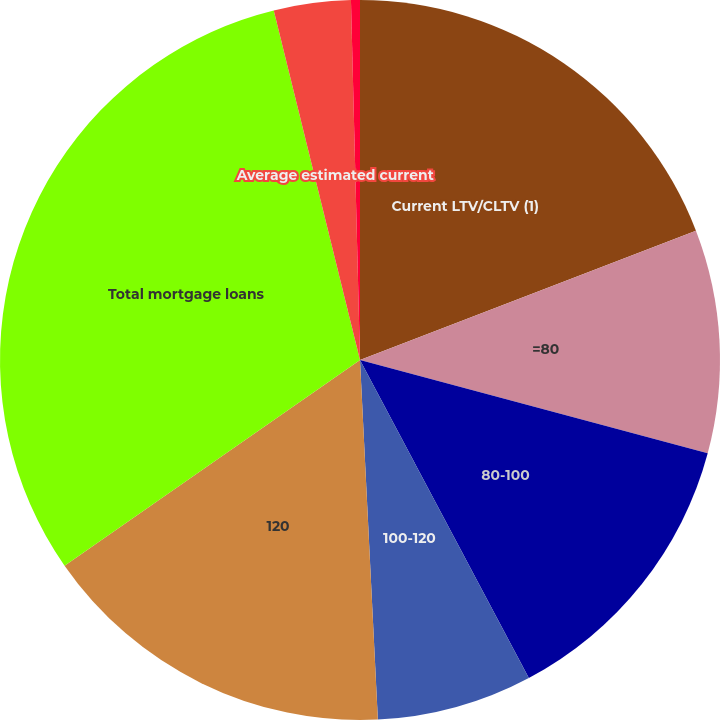Convert chart to OTSL. <chart><loc_0><loc_0><loc_500><loc_500><pie_chart><fcel>Current LTV/CLTV (1)<fcel>=80<fcel>80-100<fcel>100-120<fcel>120<fcel>Total mortgage loans<fcel>Average estimated current<fcel>Average LTV/CLTV at loan<nl><fcel>19.15%<fcel>10.02%<fcel>13.06%<fcel>6.98%<fcel>16.11%<fcel>30.83%<fcel>3.45%<fcel>0.4%<nl></chart> 